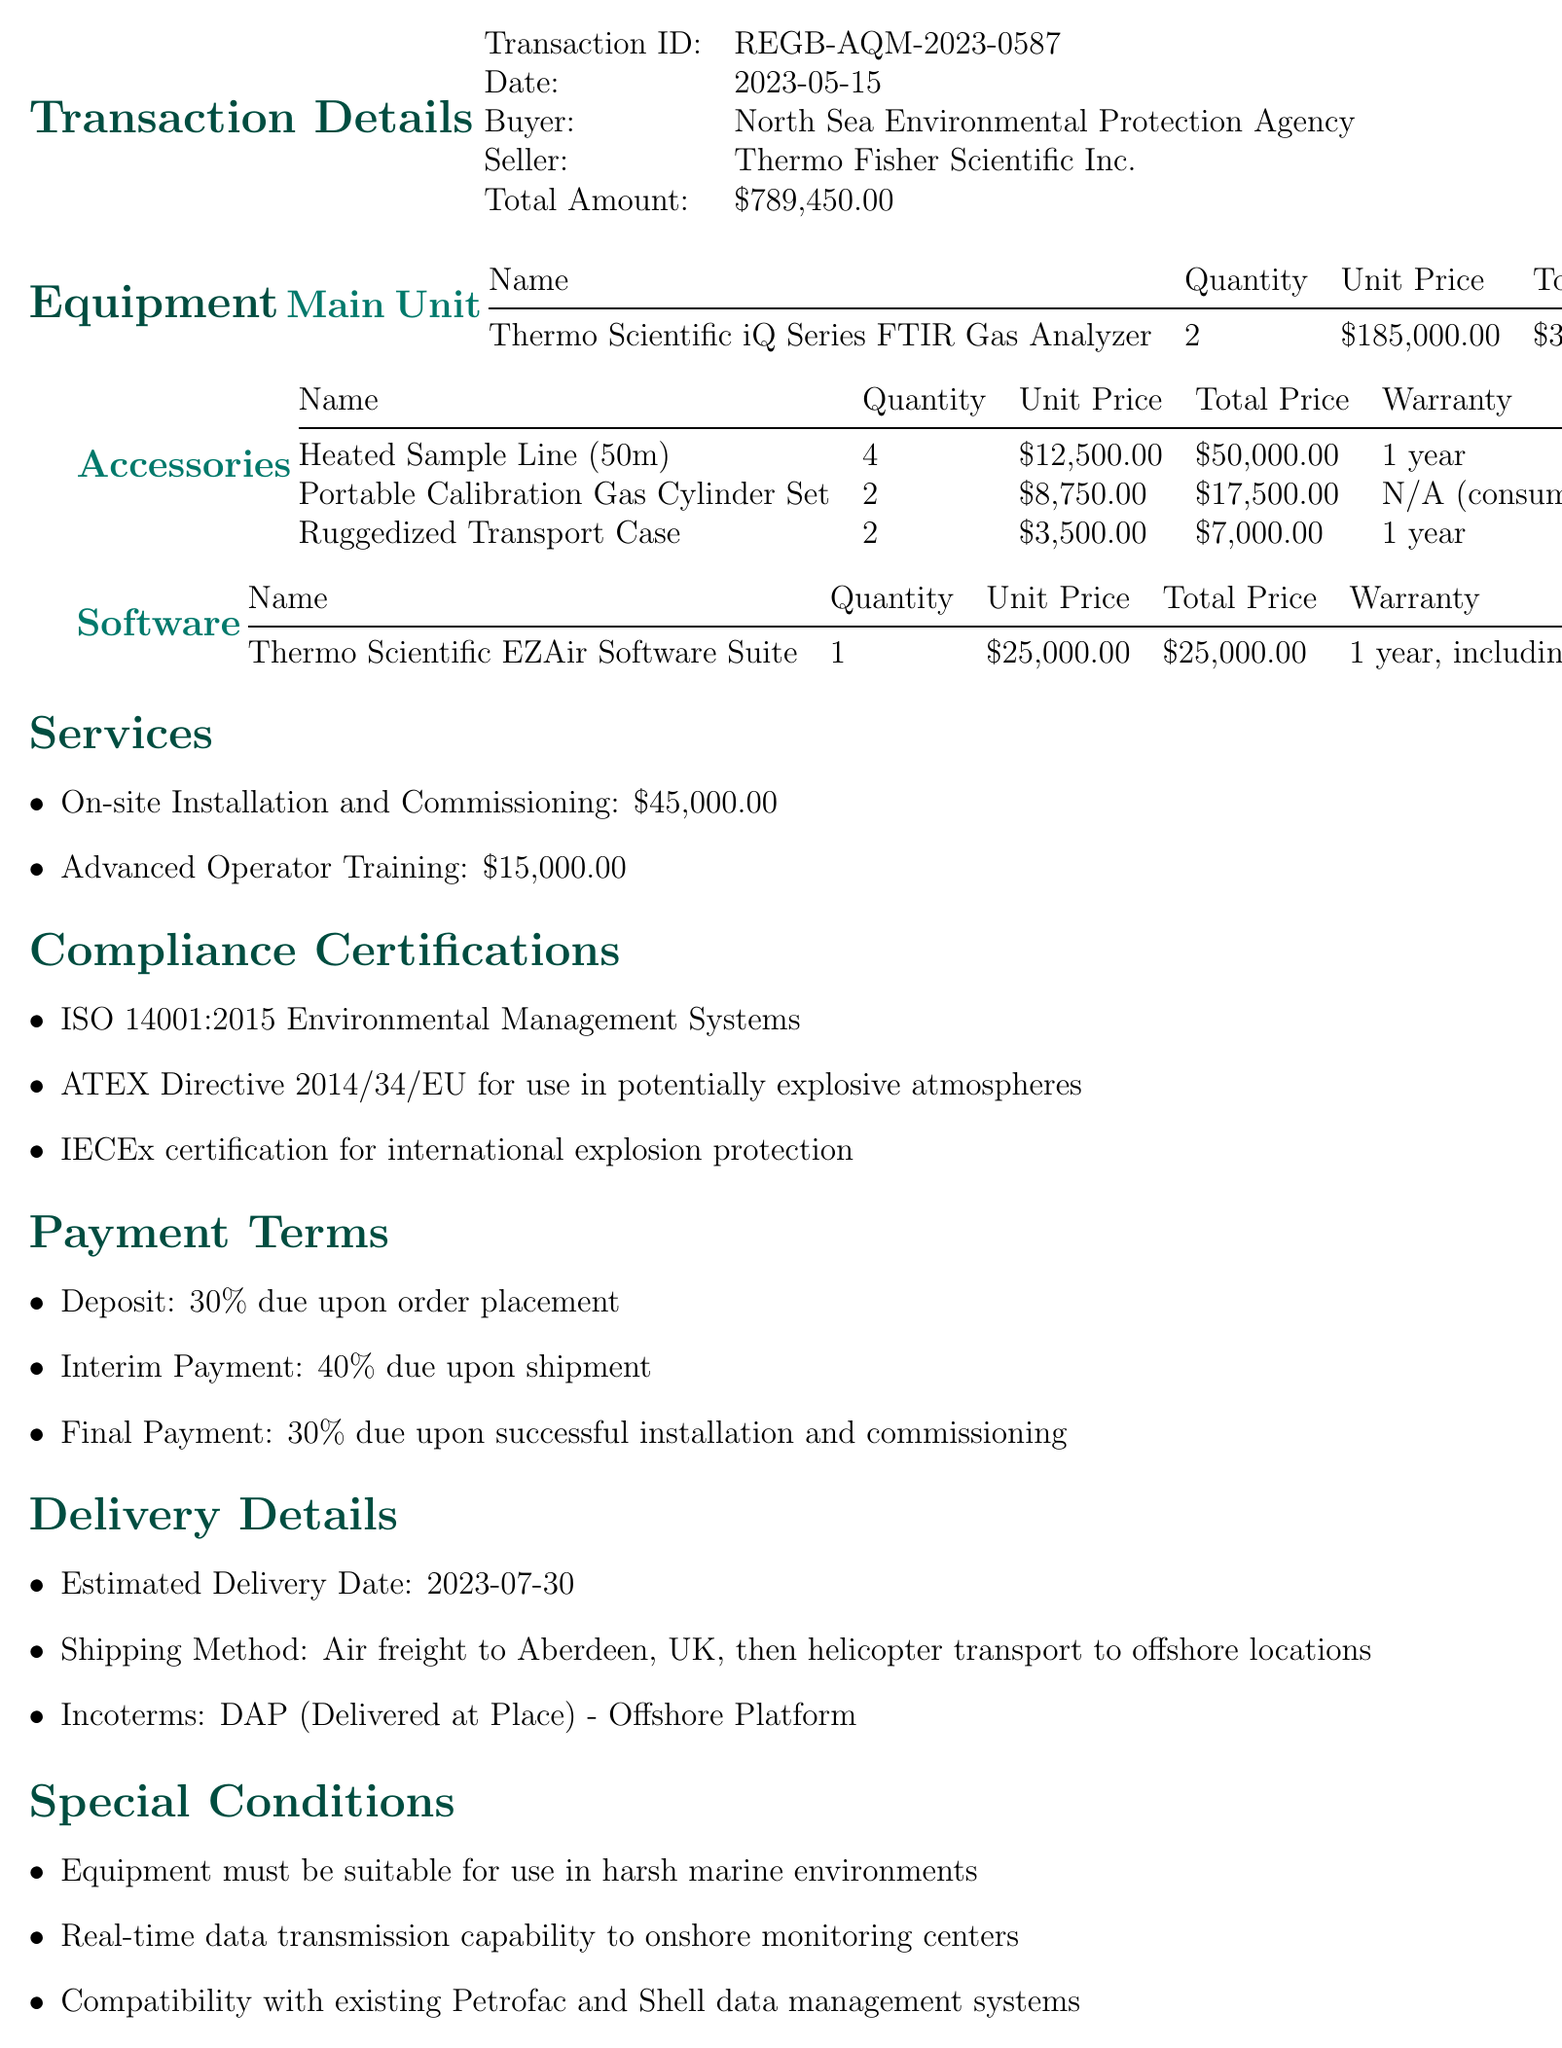what is the transaction ID? The transaction ID is explicitly listed in the document, which is REGB-AQM-2023-0587.
Answer: REGB-AQM-2023-0587 who is the buyer? The buyer is clearly stated in the document as the North Sea Environmental Protection Agency.
Answer: North Sea Environmental Protection Agency what is the total amount? The total amount is provided in the transaction details, which is $789,450.00.
Answer: $789,450.00 how many Heated Sample Lines were purchased? The number of Heated Sample Lines is noted in the accessories list as 4.
Answer: 4 what is the warranty period for the main unit? The warranty period for the main unit, the Thermo Scientific iQ Series FTIR Gas Analyzer, is mentioned as 3 years comprehensive.
Answer: 3 years comprehensive what percentage is due upon order placement? The payment terms specify that 30% is due upon order placement.
Answer: 30% what services are included in the transaction? The services section lists two services: On-site Installation and Commissioning and Advanced Operator Training.
Answer: On-site Installation and Commissioning, Advanced Operator Training when is the estimated delivery date? The document specifies that the estimated delivery date is 2023-07-30.
Answer: 2023-07-30 which certification pertains to explosion protection? The compliance certifications section lists IECEx certification for international explosion protection.
Answer: IECEx certification for international explosion protection 